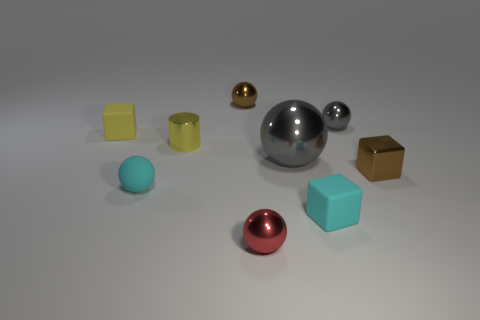There is a small shiny thing that is in front of the small yellow shiny thing and on the left side of the small brown metal block; what is its shape? The small shiny object located in front of the yellow object and to the left of the brown block has a spherical shape, which is a round 3-dimensional shape akin to a ball. 